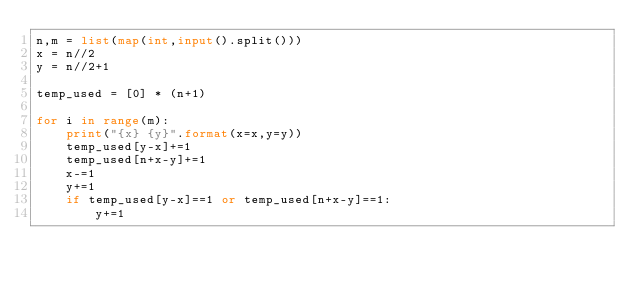<code> <loc_0><loc_0><loc_500><loc_500><_Python_>n,m = list(map(int,input().split()))
x = n//2
y = n//2+1

temp_used = [0] * (n+1)

for i in range(m):
    print("{x} {y}".format(x=x,y=y))
    temp_used[y-x]+=1
    temp_used[n+x-y]+=1
    x-=1
    y+=1
    if temp_used[y-x]==1 or temp_used[n+x-y]==1:
        y+=1
</code> 